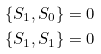Convert formula to latex. <formula><loc_0><loc_0><loc_500><loc_500>\{ S _ { 1 } , S _ { 0 } \} & = 0 \\ \{ S _ { 1 } , S _ { 1 } \} & = 0</formula> 